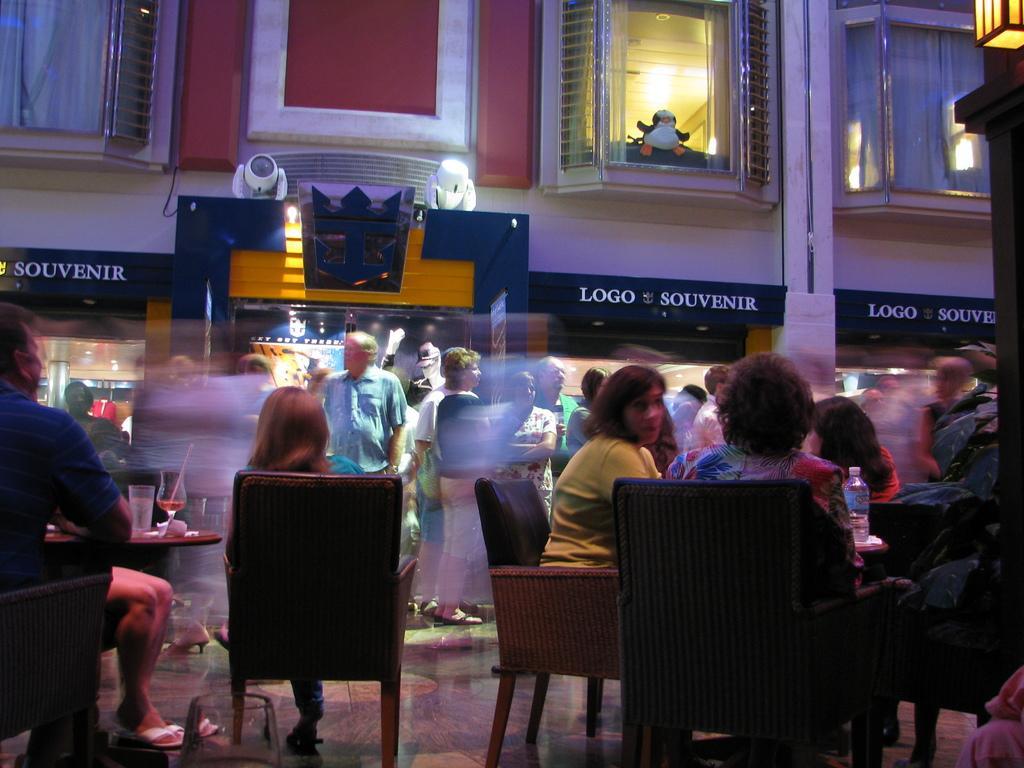Could you give a brief overview of what you see in this image? This picture consist of a building and in front of the building there are the group of persons standing and sitting on the chairs ,in front of them there is a table ,on the table there is a glass and straw on the glass seen on the left side and there is a hoarding board on the middle and there is a text written on that and there is a bottle on the table in the right side. 